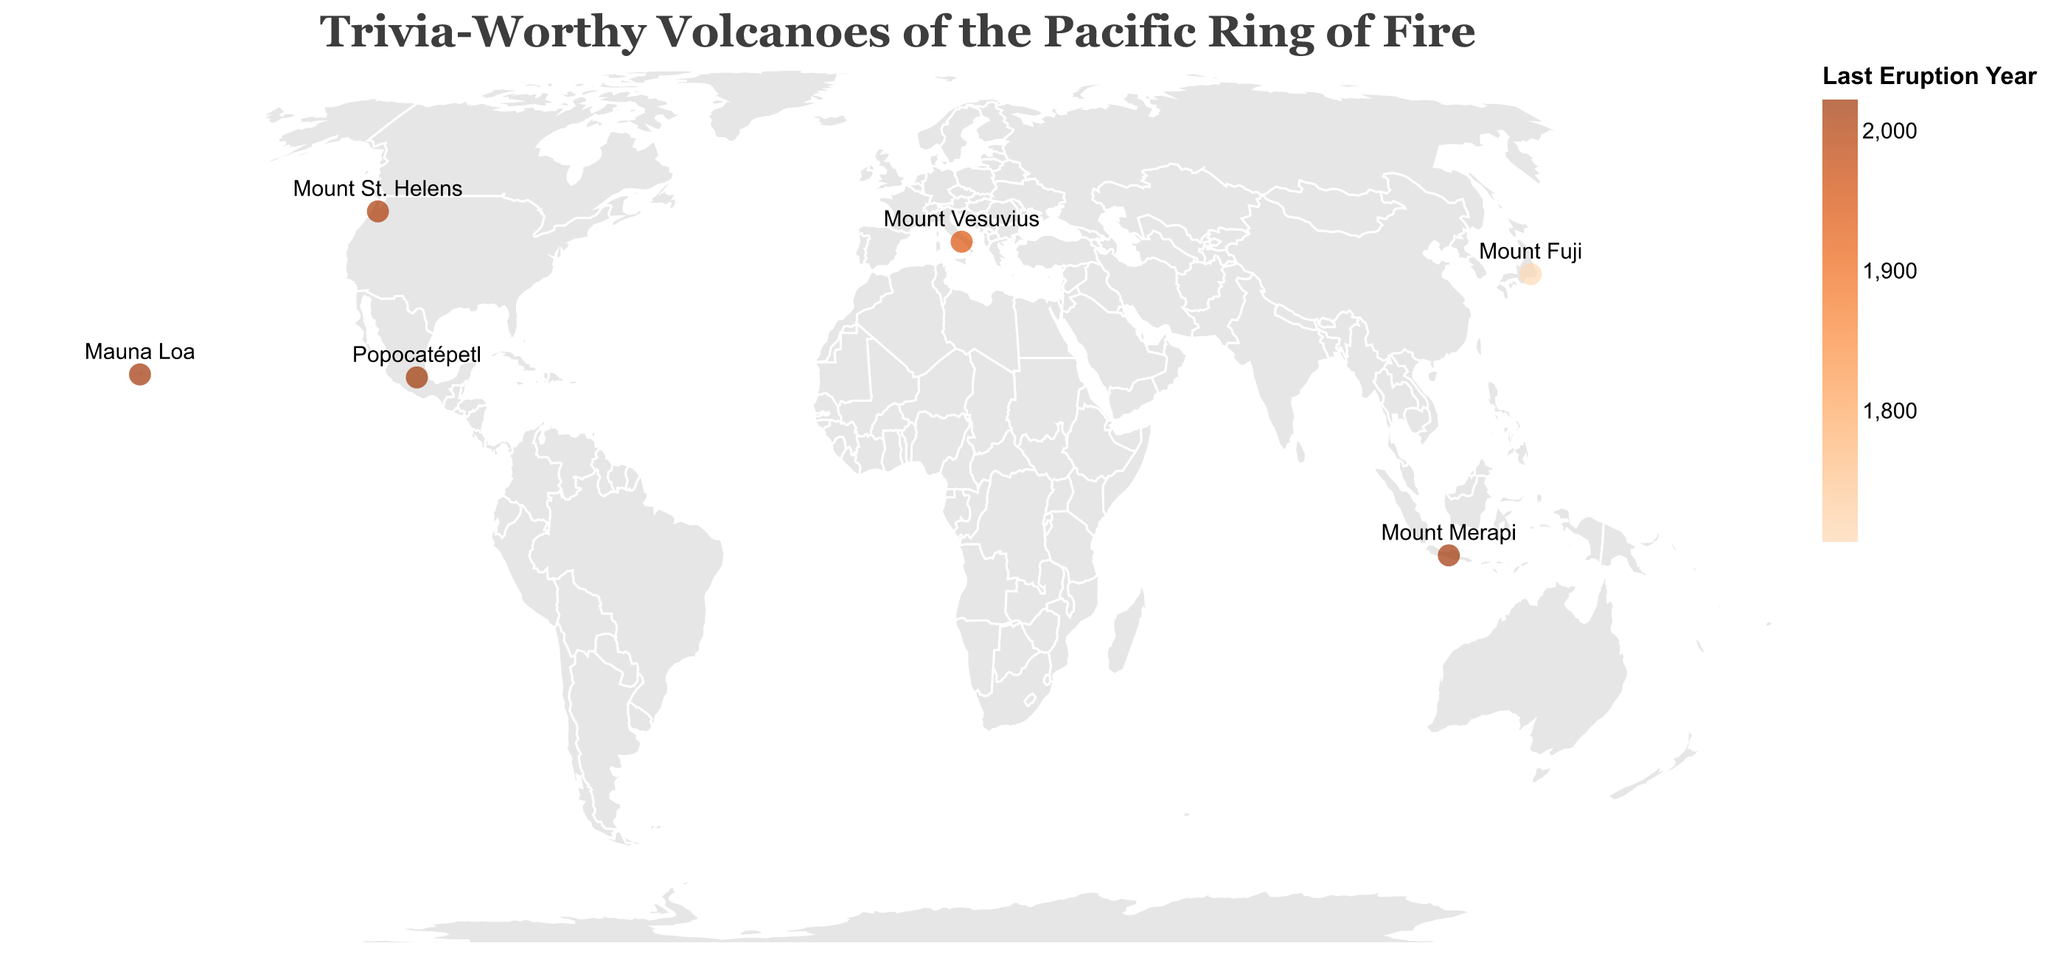What's the title of the figure? The title of the plot is displayed at the top of the figure, summarizing the content visually represented.
Answer: Trivia-Worthy Volcanoes of the Pacific Ring of Fire How many volcanoes are shown in the figure? Count the number of unique data points (circles) representing each volcano on the map.
Answer: 6 Which volcano had its last eruption most recently? Look for the volcano with the highest year value in the color legend representing the last eruption year.
Answer: Popocatépetl What color represents the volcano with the earliest last eruption year? Identify the color associated with the earliest year listed in the last eruption legend, which is 1707.
Answer: Light orange (lightest shade) Which volcano is the farthest south per the geographic data? Based on the latitude values, identify the volcano with the lowest latitude value as it represents the southern extent.
Answer: Mount Merapi Is there a higher concentration of active volcanoes in the Northern or Southern Hemisphere? By counting the number of volcanoes in the Northern and Southern Hemispheres based on latitude (positive for North and negative for South), we can compare their quantities.
Answer: Northern Hemisphere What is the longitude range of the volcanoes plotted? Determine the smallest and largest longitude values from the data to form the range.
Answer: -155.6022 to 138.7274 Which volcanoes last erupted in the 21st century? Look for volcanoes with a last eruption year of 2000 or later in the color legend and list them.
Answer: Mauna Loa, Mount St. Helens, Popocatépetl, Mount Merapi Compare the last eruption years of Mount Fuji and Mauna Loa. Which one erupted more recently? Compare the eruption years directly: Mount Fuji (1707) and Mauna Loa (2022). Mauna Loa's year is higher.
Answer: Mauna Loa What is the latitude and longitude of Mount St. Helens? Read off the latitude and longitude values from the data point labeled Mount St. Helens on the map.
Answer: 46.1914, -122.1956 